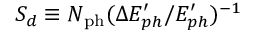Convert formula to latex. <formula><loc_0><loc_0><loc_500><loc_500>S _ { d } \equiv N _ { p h } ( \Delta E _ { p h } ^ { \prime } / E _ { p h } ^ { \prime } ) ^ { - 1 }</formula> 